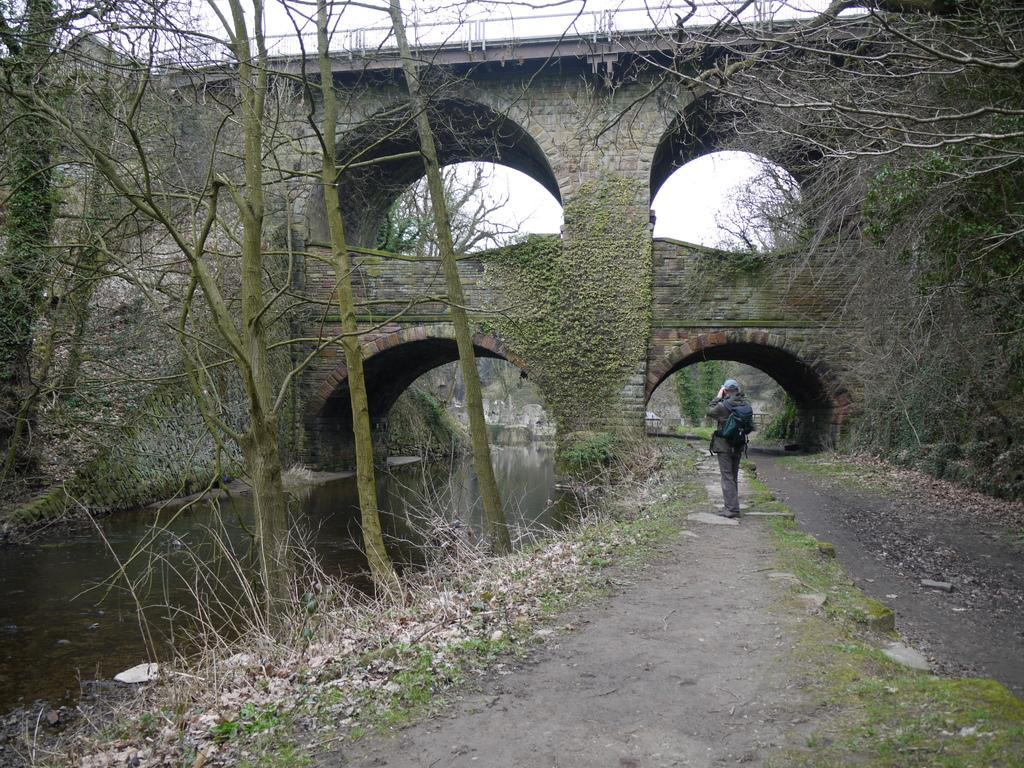What is the person in the image doing? The person is standing on the ground in the image. What is the person wearing that is visible in the image? The person is wearing a bag. What structure is in front of the person in the image? There is a bridge in front of the person in the image. What type of natural environment can be seen in the image? There are trees and a flowing river visible in the image. What type of butter can be seen melting on the bridge in the image? There is no butter present in the image; it features a person standing on the ground, a bridge, trees, and a flowing river. 